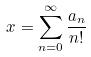<formula> <loc_0><loc_0><loc_500><loc_500>x = \sum _ { n = 0 } ^ { \infty } \frac { a _ { n } } { n ! }</formula> 